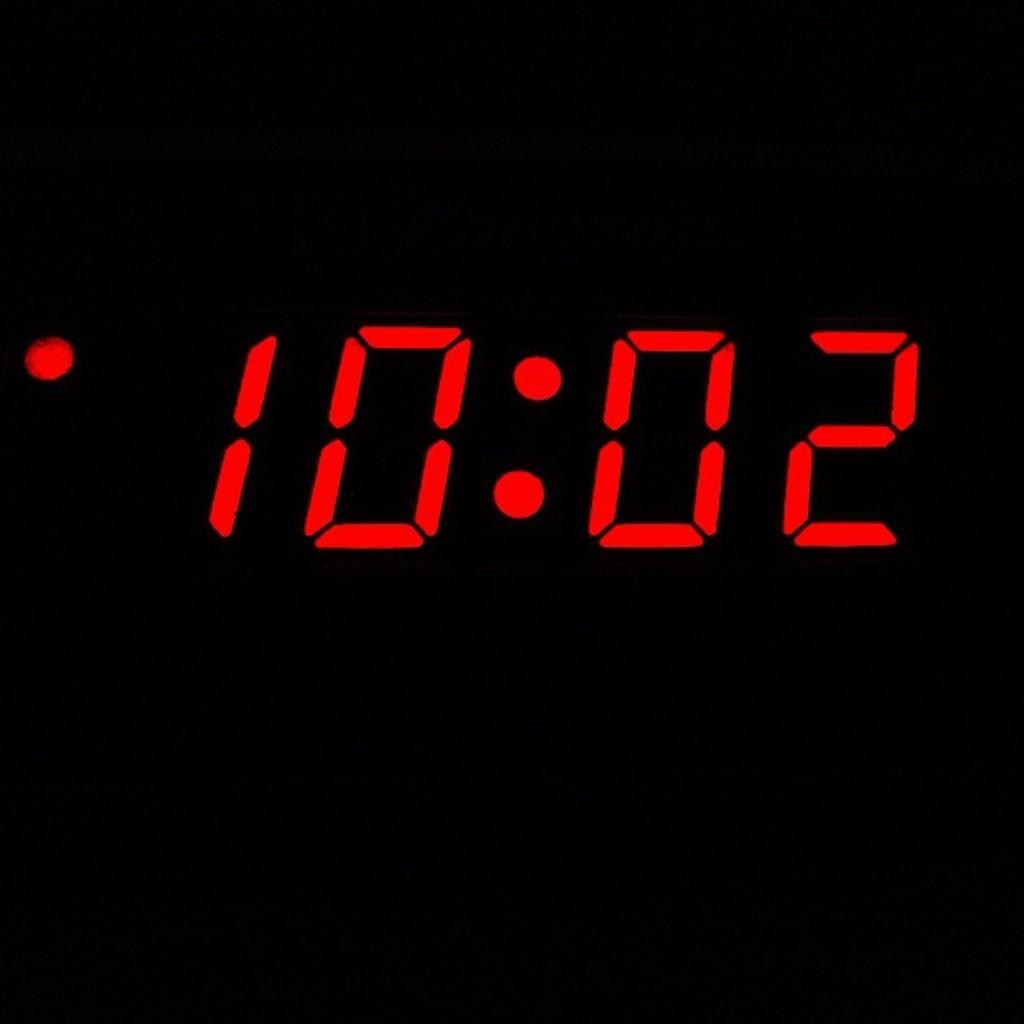Provide a one-sentence caption for the provided image. The red digital text displays that the time is 10:02. 